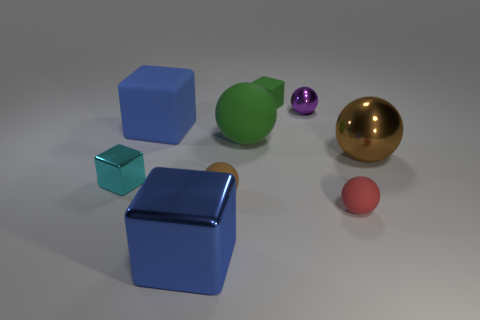What number of things are the same material as the small purple ball?
Offer a terse response. 3. Does the cyan metal object have the same size as the purple ball?
Provide a succinct answer. Yes. The big metal cube is what color?
Your answer should be very brief. Blue. How many objects are either small rubber things or tiny brown objects?
Ensure brevity in your answer.  3. Is there a cyan shiny object that has the same shape as the big blue shiny thing?
Provide a succinct answer. Yes. Does the tiny cube that is to the right of the large green matte object have the same color as the big rubber sphere?
Make the answer very short. Yes. The small metal object that is in front of the metallic thing that is to the right of the small red object is what shape?
Keep it short and to the point. Cube. Is there a metallic sphere of the same size as the cyan metal object?
Ensure brevity in your answer.  Yes. Are there fewer big things than blue blocks?
Offer a very short reply. No. There is a green rubber object on the left side of the rubber block that is right of the shiny object in front of the tiny cyan thing; what shape is it?
Provide a succinct answer. Sphere. 